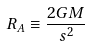<formula> <loc_0><loc_0><loc_500><loc_500>R _ { A } \equiv \frac { 2 G M } { s ^ { 2 } }</formula> 